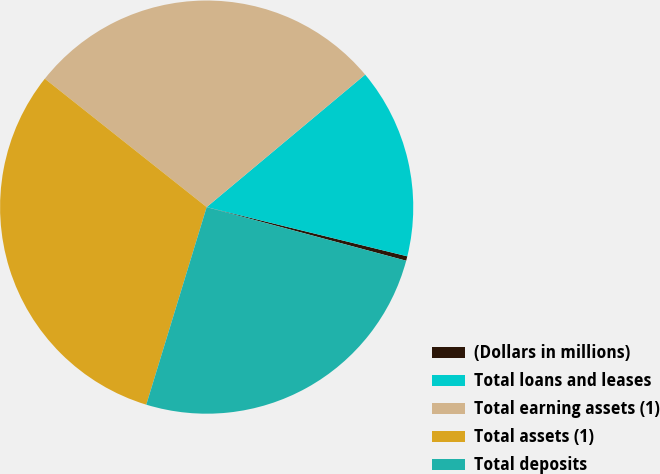Convert chart to OTSL. <chart><loc_0><loc_0><loc_500><loc_500><pie_chart><fcel>(Dollars in millions)<fcel>Total loans and leases<fcel>Total earning assets (1)<fcel>Total assets (1)<fcel>Total deposits<nl><fcel>0.35%<fcel>14.91%<fcel>28.24%<fcel>30.95%<fcel>25.54%<nl></chart> 